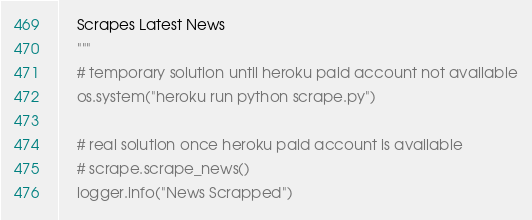<code> <loc_0><loc_0><loc_500><loc_500><_Python_>    Scrapes Latest News
    """
    # temporary solution until heroku paid account not available
    os.system("heroku run python scrape.py")

    # real solution once heroku paid account is available
    # scrape.scrape_news()
    logger.info("News Scrapped")</code> 